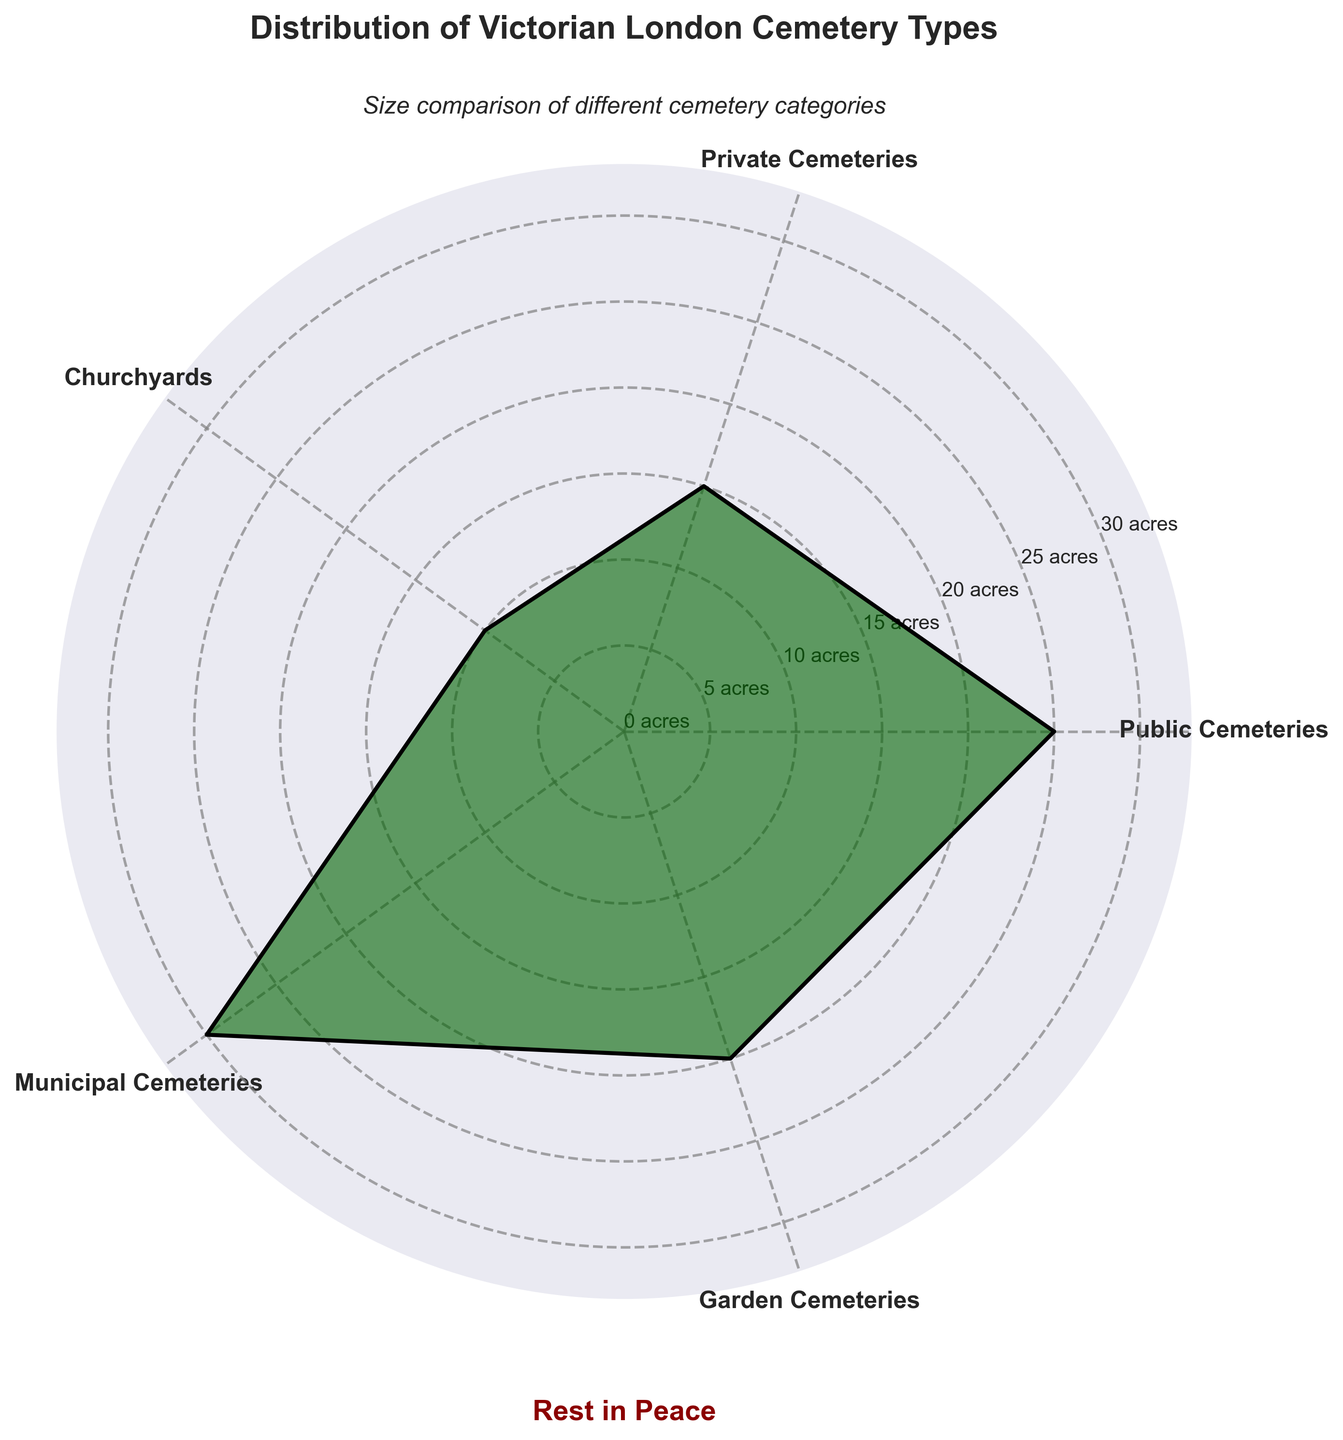What is the title of the figure? The title is found at the top of the figure, it provides an overview of the visualized data related to Victorian London cemetery types.
Answer: Distribution of Victorian London Cemetery Types How many cemetery types are represented in the chart? By counting the unique labels around the polar chart, we can see the number of different cemetery categories depicted.
Answer: 5 Which cemetery type has the largest size in acres? The largest segment in the polar area chart extends furthest from the center, denoting it as the category with the maximum size.
Answer: Municipal Cemeteries What is the size of Private Cemeteries in the chart? Locate the segment labeled "Private Cemeteries" and read the radial extension corresponding to its size in acres.
Answer: 15 acres What is the total size of Public Cemeteries and Garden Cemeteries combined? Sum the sizes of the two respective segments: Public Cemeteries (25 acres) + Garden Cemeteries (20 acres) = 45 acres.
Answer: 45 acres Which cemetery type is smaller, Churchyards or Private Cemeteries? Compare the radial lengths of the segments labeled "Churchyards" and "Private Cemeteries". The one with the shorter radial length represents the smaller size.
Answer: Churchyards How does the size of Garden Cemeteries compare to the size of Churchyards? Subtract the size of Churchyards from Garden Cemeteries: 20 - 10 = 10 acres, indicating that Garden Cemeteries is 10 acres larger.
Answer: Garden Cemeteries is 10 acres larger What is the average size of all cemetery types represented? Sum all the sizes (25 + 15 + 10 + 30 + 20 = 100 acres), then divide by the number of types (5): 100 / 5 = 20 acres.
Answer: 20 acres Which cemetery type is closest in size to 15 acres? Compare each segment's radial length to find which is nearest to the size of 15 acres. Private Cemeteries fits this criteria precisely.
Answer: Private Cemeteries What is the median size of the cemetery types presented? Order the sizes (10, 15, 20, 25, 30) and find the middle value. The median is the third value in the ordered list.
Answer: 20 acres Are there any cemetery types equal in size? Examine each segment's radial length for duplicates. All segments represent unique sizes, indicating no equal sizes.
Answer: No 